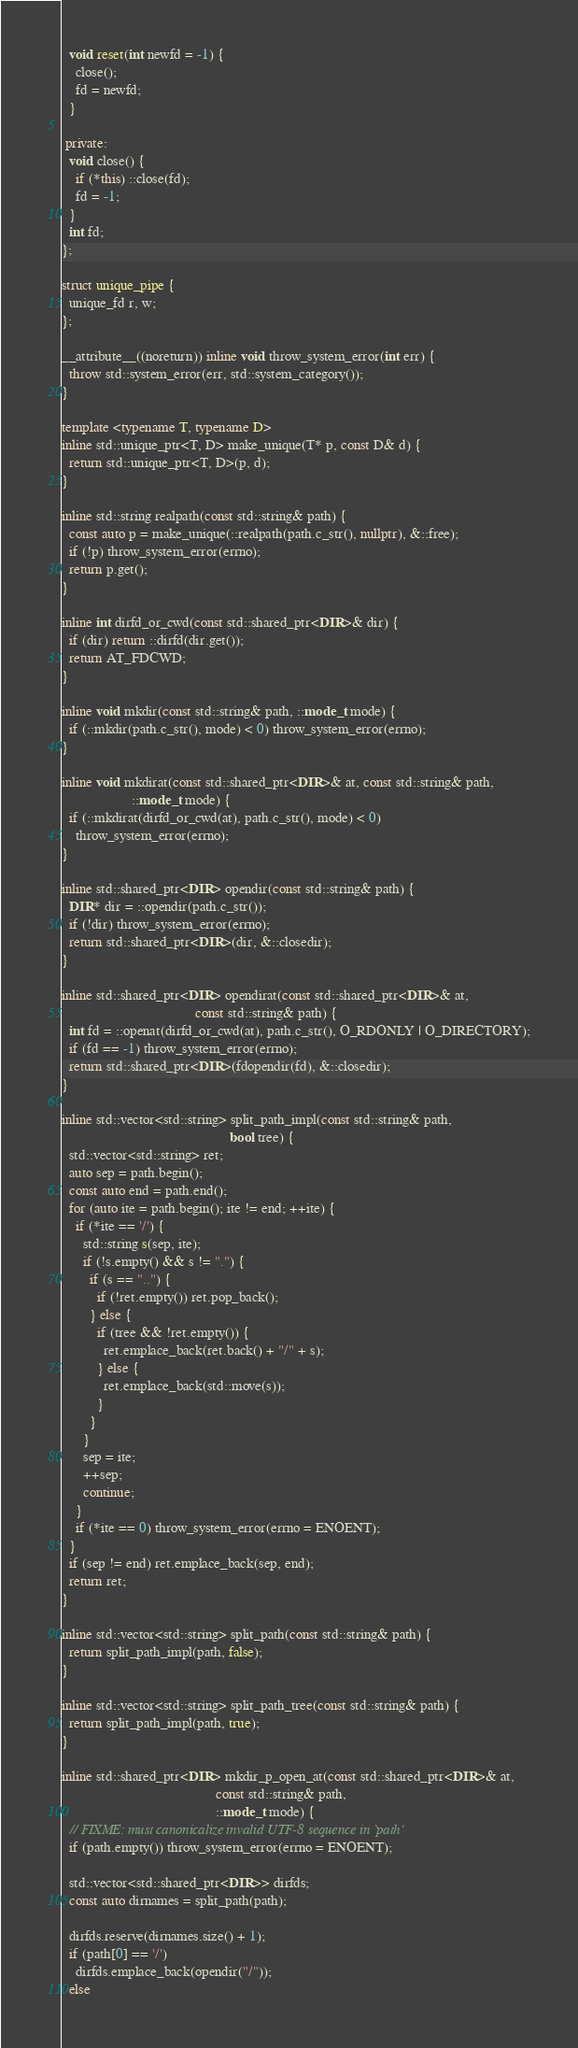Convert code to text. <code><loc_0><loc_0><loc_500><loc_500><_C++_>  void reset(int newfd = -1) {
    close();
    fd = newfd;
  }

 private:
  void close() {
    if (*this) ::close(fd);
    fd = -1;
  }
  int fd;
};

struct unique_pipe {
  unique_fd r, w;
};

__attribute__((noreturn)) inline void throw_system_error(int err) {
  throw std::system_error(err, std::system_category());
}

template <typename T, typename D>
inline std::unique_ptr<T, D> make_unique(T* p, const D& d) {
  return std::unique_ptr<T, D>(p, d);
}

inline std::string realpath(const std::string& path) {
  const auto p = make_unique(::realpath(path.c_str(), nullptr), &::free);
  if (!p) throw_system_error(errno);
  return p.get();
}

inline int dirfd_or_cwd(const std::shared_ptr<DIR>& dir) {
  if (dir) return ::dirfd(dir.get());
  return AT_FDCWD;
}

inline void mkdir(const std::string& path, ::mode_t mode) {
  if (::mkdir(path.c_str(), mode) < 0) throw_system_error(errno);
}

inline void mkdirat(const std::shared_ptr<DIR>& at, const std::string& path,
                    ::mode_t mode) {
  if (::mkdirat(dirfd_or_cwd(at), path.c_str(), mode) < 0)
    throw_system_error(errno);
}

inline std::shared_ptr<DIR> opendir(const std::string& path) {
  DIR* dir = ::opendir(path.c_str());
  if (!dir) throw_system_error(errno);
  return std::shared_ptr<DIR>(dir, &::closedir);
}

inline std::shared_ptr<DIR> opendirat(const std::shared_ptr<DIR>& at,
                                      const std::string& path) {
  int fd = ::openat(dirfd_or_cwd(at), path.c_str(), O_RDONLY | O_DIRECTORY);
  if (fd == -1) throw_system_error(errno);
  return std::shared_ptr<DIR>(fdopendir(fd), &::closedir);
}

inline std::vector<std::string> split_path_impl(const std::string& path,
                                                bool tree) {
  std::vector<std::string> ret;
  auto sep = path.begin();
  const auto end = path.end();
  for (auto ite = path.begin(); ite != end; ++ite) {
    if (*ite == '/') {
      std::string s(sep, ite);
      if (!s.empty() && s != ".") {
        if (s == "..") {
          if (!ret.empty()) ret.pop_back();
        } else {
          if (tree && !ret.empty()) {
            ret.emplace_back(ret.back() + "/" + s);
          } else {
            ret.emplace_back(std::move(s));
          }
        }
      }
      sep = ite;
      ++sep;
      continue;
    }
    if (*ite == 0) throw_system_error(errno = ENOENT);
  }
  if (sep != end) ret.emplace_back(sep, end);
  return ret;
}

inline std::vector<std::string> split_path(const std::string& path) {
  return split_path_impl(path, false);
}

inline std::vector<std::string> split_path_tree(const std::string& path) {
  return split_path_impl(path, true);
}

inline std::shared_ptr<DIR> mkdir_p_open_at(const std::shared_ptr<DIR>& at,
                                            const std::string& path,
                                            ::mode_t mode) {
  // FIXME: must canonicalize invalid UTF-8 sequence in `path'
  if (path.empty()) throw_system_error(errno = ENOENT);

  std::vector<std::shared_ptr<DIR>> dirfds;
  const auto dirnames = split_path(path);

  dirfds.reserve(dirnames.size() + 1);
  if (path[0] == '/')
    dirfds.emplace_back(opendir("/"));
  else</code> 